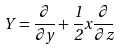<formula> <loc_0><loc_0><loc_500><loc_500>Y = \frac { \partial } { \partial y } + \frac { 1 } { 2 } x \frac { \partial } { \partial z }</formula> 